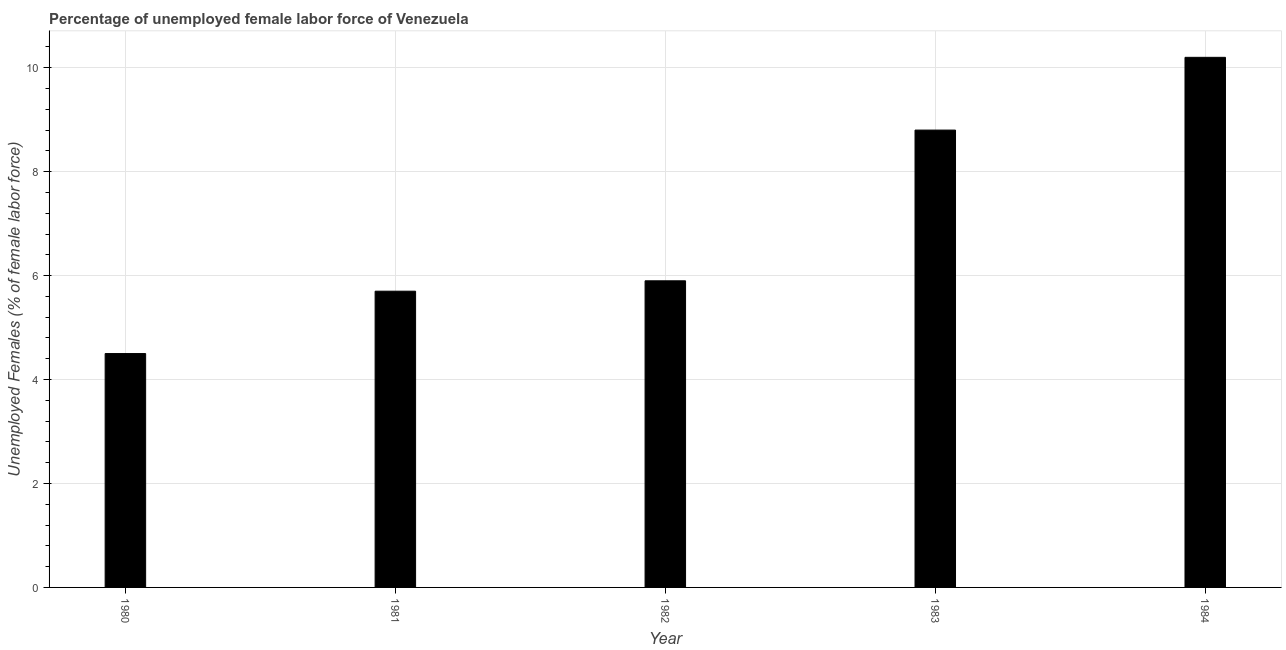Does the graph contain grids?
Ensure brevity in your answer.  Yes. What is the title of the graph?
Ensure brevity in your answer.  Percentage of unemployed female labor force of Venezuela. What is the label or title of the Y-axis?
Offer a terse response. Unemployed Females (% of female labor force). What is the total unemployed female labour force in 1980?
Your answer should be compact. 4.5. Across all years, what is the maximum total unemployed female labour force?
Offer a terse response. 10.2. What is the sum of the total unemployed female labour force?
Keep it short and to the point. 35.1. What is the average total unemployed female labour force per year?
Offer a terse response. 7.02. What is the median total unemployed female labour force?
Provide a succinct answer. 5.9. What is the ratio of the total unemployed female labour force in 1983 to that in 1984?
Ensure brevity in your answer.  0.86. Is the total unemployed female labour force in 1981 less than that in 1983?
Offer a terse response. Yes. Is the difference between the total unemployed female labour force in 1982 and 1984 greater than the difference between any two years?
Keep it short and to the point. No. What is the difference between the highest and the lowest total unemployed female labour force?
Ensure brevity in your answer.  5.7. How many bars are there?
Provide a short and direct response. 5. Are all the bars in the graph horizontal?
Offer a terse response. No. How many years are there in the graph?
Your response must be concise. 5. What is the Unemployed Females (% of female labor force) of 1981?
Ensure brevity in your answer.  5.7. What is the Unemployed Females (% of female labor force) in 1982?
Your response must be concise. 5.9. What is the Unemployed Females (% of female labor force) in 1983?
Offer a very short reply. 8.8. What is the Unemployed Females (% of female labor force) of 1984?
Provide a succinct answer. 10.2. What is the difference between the Unemployed Females (% of female labor force) in 1980 and 1982?
Your response must be concise. -1.4. What is the difference between the Unemployed Females (% of female labor force) in 1980 and 1984?
Ensure brevity in your answer.  -5.7. What is the difference between the Unemployed Females (% of female labor force) in 1981 and 1982?
Ensure brevity in your answer.  -0.2. What is the difference between the Unemployed Females (% of female labor force) in 1981 and 1983?
Offer a terse response. -3.1. What is the difference between the Unemployed Females (% of female labor force) in 1981 and 1984?
Offer a very short reply. -4.5. What is the difference between the Unemployed Females (% of female labor force) in 1982 and 1984?
Make the answer very short. -4.3. What is the difference between the Unemployed Females (% of female labor force) in 1983 and 1984?
Offer a very short reply. -1.4. What is the ratio of the Unemployed Females (% of female labor force) in 1980 to that in 1981?
Offer a very short reply. 0.79. What is the ratio of the Unemployed Females (% of female labor force) in 1980 to that in 1982?
Your answer should be very brief. 0.76. What is the ratio of the Unemployed Females (% of female labor force) in 1980 to that in 1983?
Your answer should be very brief. 0.51. What is the ratio of the Unemployed Females (% of female labor force) in 1980 to that in 1984?
Give a very brief answer. 0.44. What is the ratio of the Unemployed Females (% of female labor force) in 1981 to that in 1982?
Your answer should be compact. 0.97. What is the ratio of the Unemployed Females (% of female labor force) in 1981 to that in 1983?
Your answer should be very brief. 0.65. What is the ratio of the Unemployed Females (% of female labor force) in 1981 to that in 1984?
Give a very brief answer. 0.56. What is the ratio of the Unemployed Females (% of female labor force) in 1982 to that in 1983?
Offer a very short reply. 0.67. What is the ratio of the Unemployed Females (% of female labor force) in 1982 to that in 1984?
Your answer should be very brief. 0.58. What is the ratio of the Unemployed Females (% of female labor force) in 1983 to that in 1984?
Offer a very short reply. 0.86. 